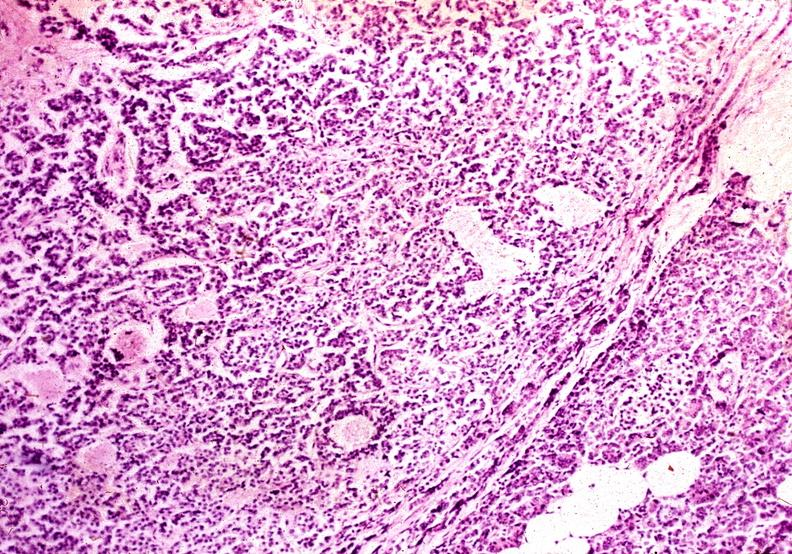s no cystic aortic lesions present?
Answer the question using a single word or phrase. No 